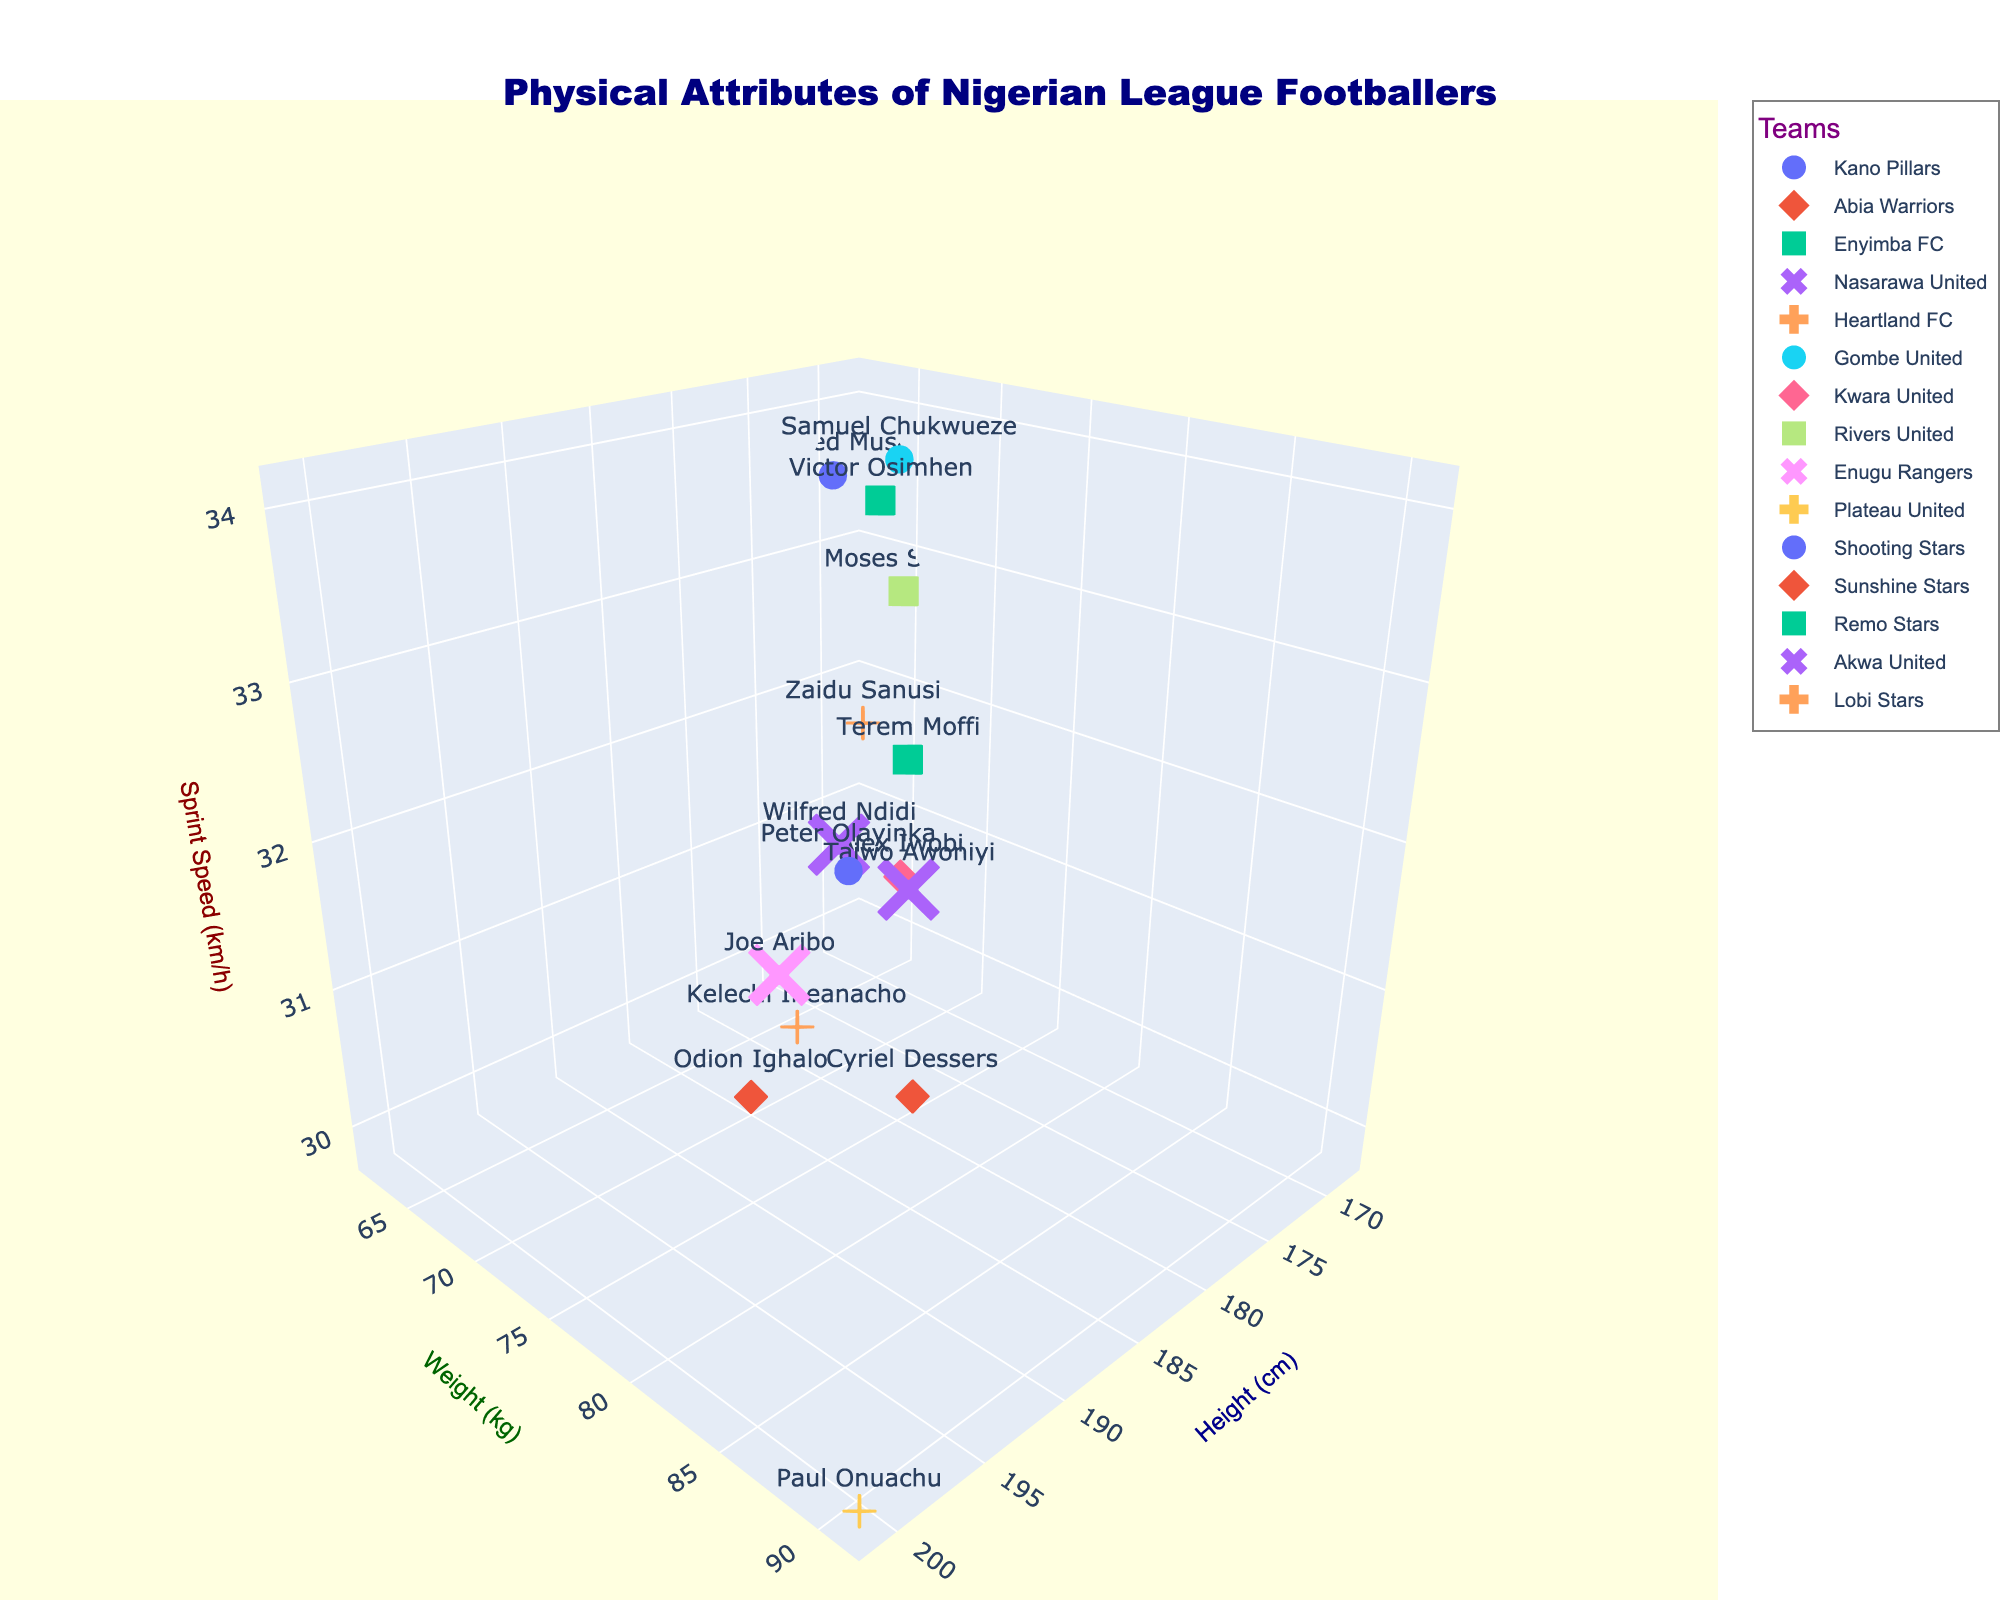What's the title of the chart? The title is found at the top of the chart, which summarizes the overall content.
Answer: Physical Attributes of Nigerian League Footballers What does the x-axis represent? The label on the x-axis indicates what it measures, which is located at the bottom horizontal axis of the 3D scatter plot.
Answer: Height (cm) Which team has the tallest player? The tallest player can be identified by the highest position along the x-axis (Height in cm) and matching the player with their respective team using the team colors and symbols.
Answer: Plateau United Which player has the highest sprint speed? The player with the highest sprint speed can be identified by looking at the topmost point along the z-axis (Sprint Speed in km/h).
Answer: Victor Osimhen How many players are from teams with an average weight above 75 kg? List the players from each team and calculate the average weight of each team. Count the players from teams with average weights above 75 kg.
Answer: 7 Which two players have a similar height but different sprint speeds? Compare the height values along the x-axis to find players with similar heights, then compare their positions along the z-axis to check for differences in sprint speeds.
Answer: Kelechi Iheanacho and Odion Ighalo Compare the weight of the shortest and tallest players and determine the difference. Identify the shortest and tallest players by comparing the x-axis values, then read their corresponding weight from the y-axis and calculate the difference.
Answer: 29 kg Which player from Enugu Rangers has the highest sprint speed? Locate players from Enugu Rangers using their team color and symbol, then find which one has the highest position on the z-axis indicating Sprint Speed.
Answer: Joe Aribo What is the range of heights for players from teams in the chart? Identify the minimum and maximum height values from the x-axis by analyzing the positions of data points across all teams. Subtract the minimum from the maximum to find the range.
Answer: 33 cm Which team has the most evenly distributed weights among their players? Examine the spread of weights along the y-axis for each team and identify the team whose data points are most evenly spread.
Answer: Enugu Rangers 